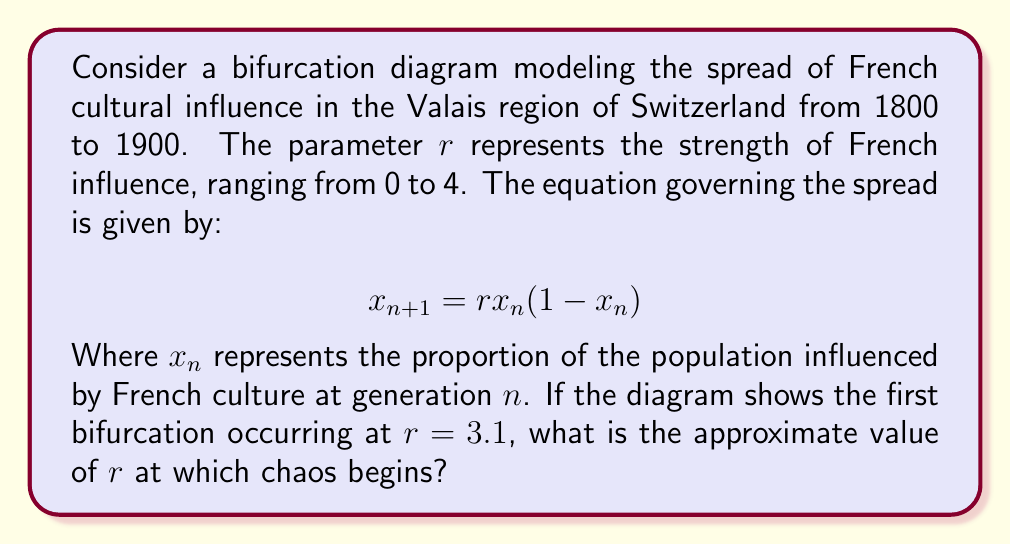Could you help me with this problem? To solve this problem, we need to understand the behavior of the logistic map and its bifurcation diagram:

1. The logistic map $x_{n+1} = rx_n(1-x_n)$ is a classic example in chaos theory.

2. As $r$ increases, the system undergoes a series of period-doubling bifurcations.

3. The first bifurcation occurs at $r = 3$, which in this case is given as 3.1.

4. Subsequent bifurcations occur at shorter intervals, following a geometric sequence.

5. The ratio between successive bifurcation intervals converges to the Feigenbaum constant, δ ≈ 4.669201.

6. The onset of chaos occurs after an infinite number of bifurcations, at a value known as $r_∞$.

7. The relationship between $r_∞$ and the first bifurcation point $r_1$ is approximately:

   $$r_∞ ≈ r_1 + \frac{r_2 - r_1}{δ - 1}$$

   where $r_2$ is the second bifurcation point.

8. We don't know $r_2$, but we can estimate it using the Feigenbaum constant:

   $$r_2 ≈ r_1 + \frac{r_1 - 3}{δ}$$

9. Substituting $r_1 = 3.1$ and δ ≈ 4.669201:

   $$r_2 ≈ 3.1 + \frac{3.1 - 3}{4.669201} ≈ 3.12140$$

10. Now we can estimate $r_∞$:

    $$r_∞ ≈ 3.1 + \frac{3.12140 - 3.1}{4.669201 - 1} ≈ 3.56995$$

Therefore, chaos begins at approximately $r = 3.57$.
Answer: $r ≈ 3.57$ 